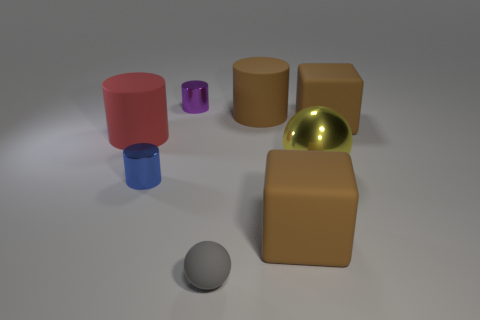There is a yellow metallic ball; is its size the same as the matte cylinder that is left of the small purple cylinder? The yellow metallic ball appears to be roughly the same size as the matte cylinder to the left of the small purple cylinder, although without measuring tools it's difficult to ascertain absolute equivalence of dimensions. 